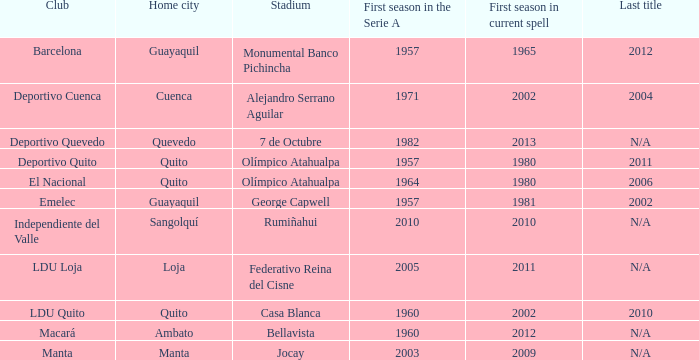State the opening season of the 2006 series. 1964.0. 